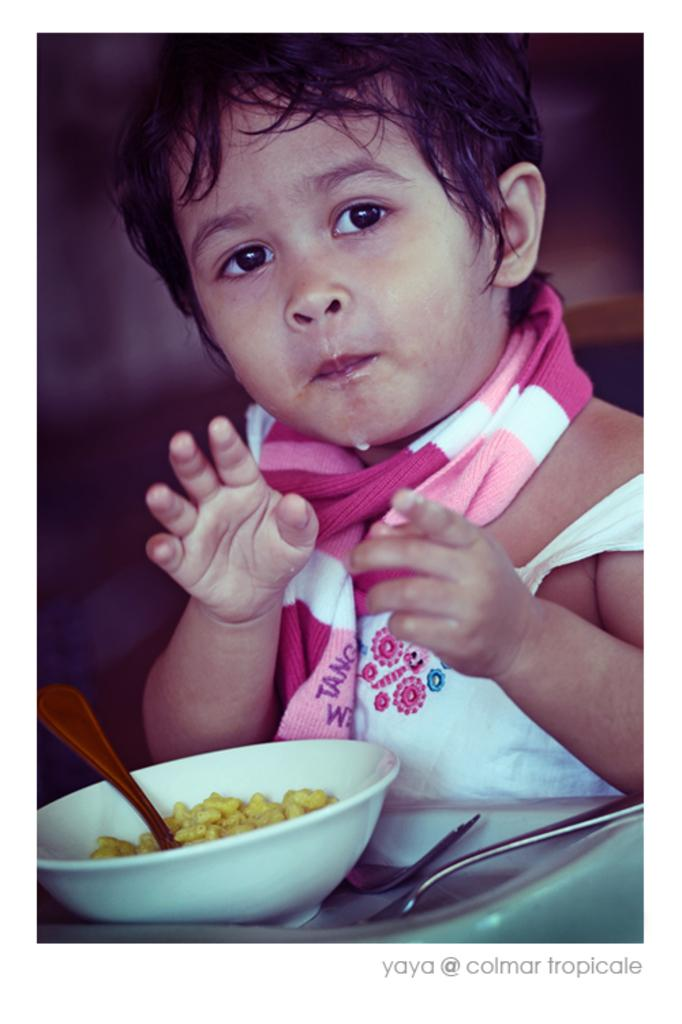What is the main subject of the image? The main subject of the image is a kid. What is in front of the kid? There is a bowl in front of the kid. What is the kid doing with the bowl? The kid is eating something from the bowl. What utensil is present in the bowl? There is a spoon in the bowl. What is inside the bowl that the kid is eating? There are eatables in the bowl. Can you see any icicles hanging from the kid's hair in the image? There are no icicles present in the image. Is there a man in the image helping the kid eat the food? There is no man present in the image; it only shows a kid eating from a bowl. 